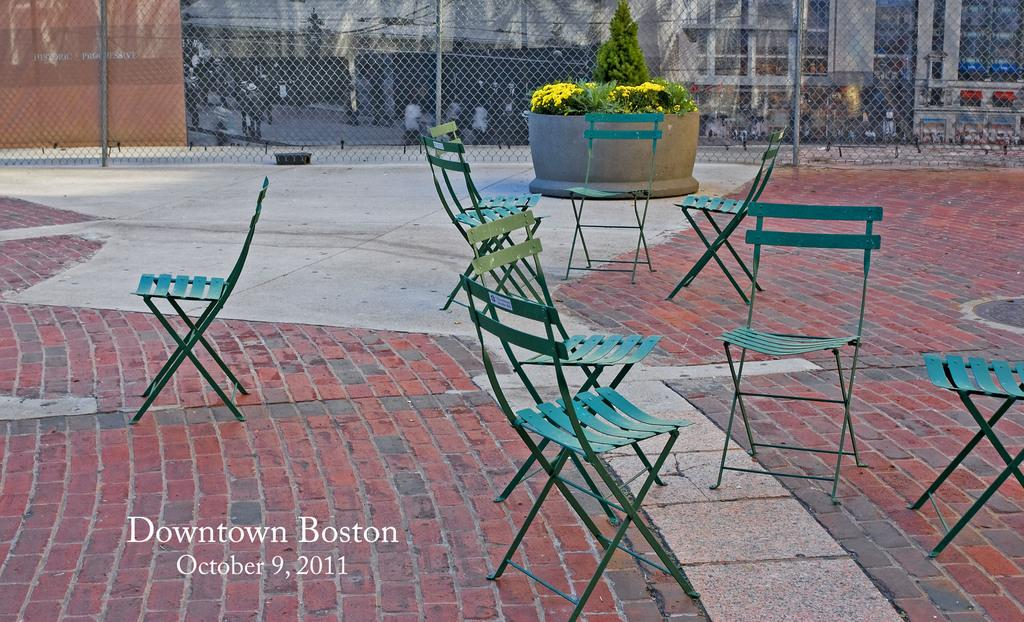What type of furniture is present in the image? There are chairs in the image. What type of vegetation can be seen in the image? There is a plant in the image. What type of barrier is present in the image? There is a metal fence in the image. What type of structure is visible in the image? There is a building visible in the image. What type of rings are being used to hold the basket in the image? There is no basket or rings present in the image. 